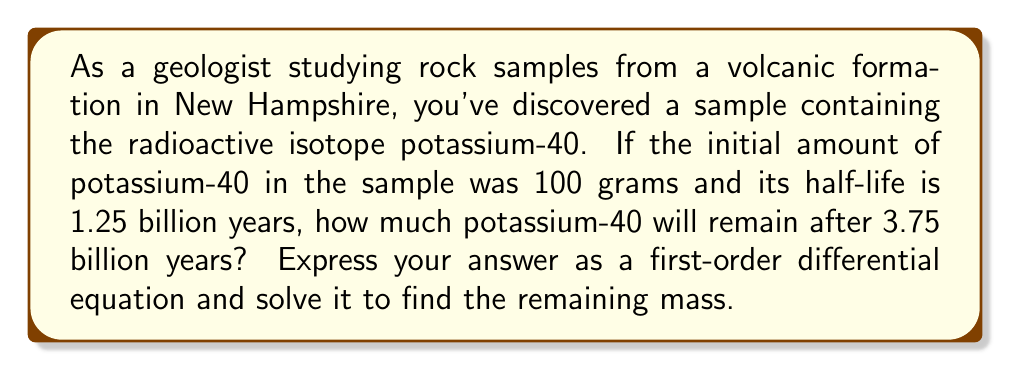Help me with this question. Let's approach this step-by-step:

1) First, we need to set up the differential equation. Let $m(t)$ be the mass of potassium-40 at time $t$ (in billions of years). The rate of decay is proportional to the amount present:

   $$\frac{dm}{dt} = -km$$

   where $k$ is the decay constant.

2) To find $k$, we use the half-life formula:

   $$T_{1/2} = \frac{\ln(2)}{k}$$

   $$k = \frac{\ln(2)}{T_{1/2}} = \frac{\ln(2)}{1.25} = 0.5545$$

3) Now our differential equation is:

   $$\frac{dm}{dt} = -0.5545m$$

4) This is a separable equation. Let's solve it:

   $$\int \frac{dm}{m} = \int -0.5545 dt$$

   $$\ln|m| = -0.5545t + C$$

5) To find $C$, we use the initial condition: $m(0) = 100$

   $$\ln(100) = C$$
   $$C = 4.6052$$

6) So our solution is:

   $$\ln|m| = -0.5545t + 4.6052$$
   $$m(t) = e^{-0.5545t + 4.6052} = 100e^{-0.5545t}$$

7) Now we can find the mass after 3.75 billion years:

   $$m(3.75) = 100e^{-0.5545(3.75)} = 12.5$$

Therefore, after 3.75 billion years, approximately 12.5 grams of potassium-40 will remain.
Answer: The first-order differential equation is $\frac{dm}{dt} = -0.5545m$ with initial condition $m(0) = 100$. The solution is $m(t) = 100e^{-0.5545t}$, and the remaining mass after 3.75 billion years is approximately 12.5 grams. 